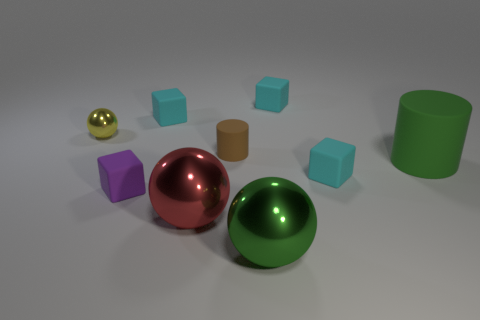There is a large shiny thing left of the small cylinder; is its shape the same as the cyan thing in front of the big matte object? No, the large shiny object to the left of the small cylinder, which appears to be a red sphere, is not the same shape as the cyan object, which is a cube. The sphere has a continuous surface without edges, while the cube has flat faces and edges. 